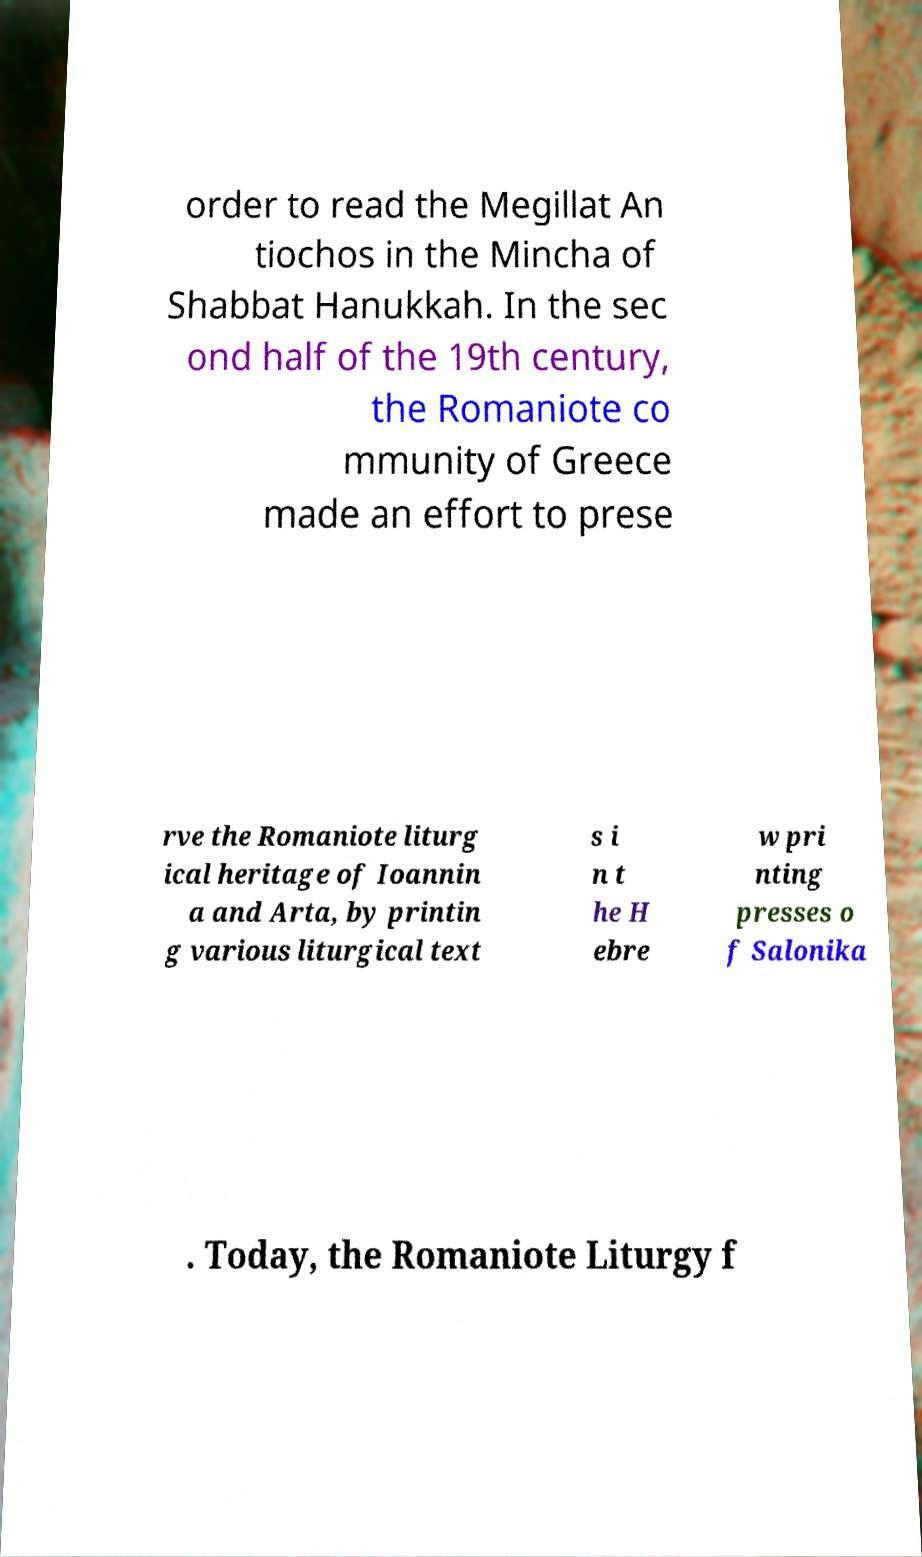Can you accurately transcribe the text from the provided image for me? order to read the Megillat An tiochos in the Mincha of Shabbat Hanukkah. In the sec ond half of the 19th century, the Romaniote co mmunity of Greece made an effort to prese rve the Romaniote liturg ical heritage of Ioannin a and Arta, by printin g various liturgical text s i n t he H ebre w pri nting presses o f Salonika . Today, the Romaniote Liturgy f 